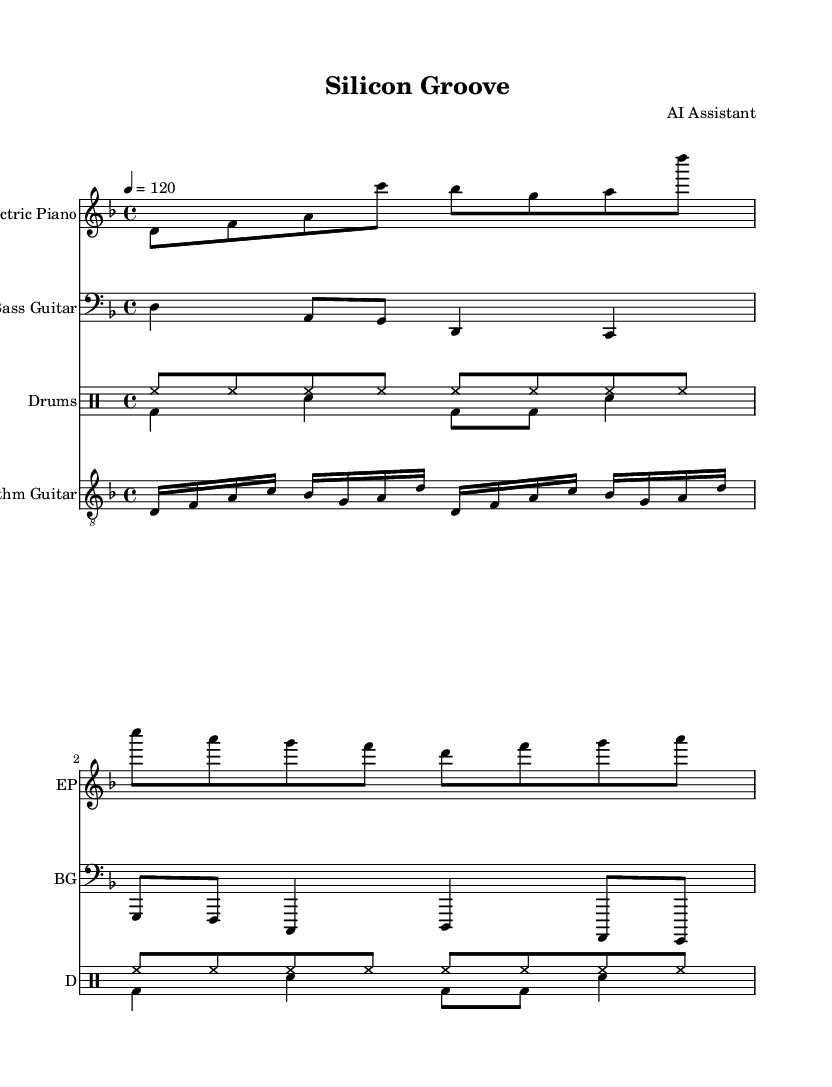What is the key signature of this music? The key signature is indicated at the beginning of the staff lines with sharps or flats, and for this piece, the absence of any sharps or flats points to it being D minor.
Answer: D minor What is the time signature of this music? The time signature is displayed at the beginning of the music and shows how many beats are in each measure. Here, it is 4/4, meaning there are four beats in each measure.
Answer: 4/4 What is the tempo of the piece? The tempo is indicated above the staff with a number and term, and in this case, it is marked as 120 beats per minute, which indicates the speed of the piece.
Answer: 120 How many measures are in the electric piano part? By examining the electric piano part, we can count the number of complete measures. Each set of four beats constitutes one measure, and this part has a total of four measures.
Answer: 4 How many distinct instruments are used in this piece? We can count the separate staves labeled for each instrument in the score. The piece includes an electric piano, bass guitar, rhythm guitar, and drums, totaling four distinct instruments.
Answer: 4 What type of rhythms are primarily used in the drums section? The rhythms in the drums are indicated in the drummode section, which shows a mix of hi-hat patterns and kick-drum patterns. Most prevalent are repeated hi-hats and single bass drum hits.
Answer: Funky What kind of groove is suggested by the rhythm of the electric piano? The rhythmic structure in the electric piano has a syncopated feel, suggesting a laid-back, funky groove characteristic of soul music, which focuses on groove and flow.
Answer: Funky groove 